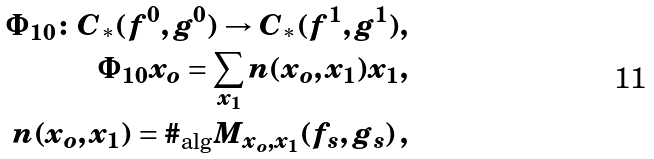<formula> <loc_0><loc_0><loc_500><loc_500>\Phi _ { 1 0 } \colon C _ { \ast } ( f ^ { 0 } , g ^ { 0 } ) \to C _ { \ast } ( f ^ { 1 } , g ^ { 1 } ) , \\ \Phi _ { 1 0 } x _ { o } = \sum _ { x _ { 1 } } n ( x _ { o } , x _ { 1 } ) x _ { 1 } , \\ n ( x _ { o } , x _ { 1 } ) = \# _ { \text {alg} } M _ { x _ { o } , x _ { 1 } } ( f _ { s } , g _ { s } ) \, ,</formula> 